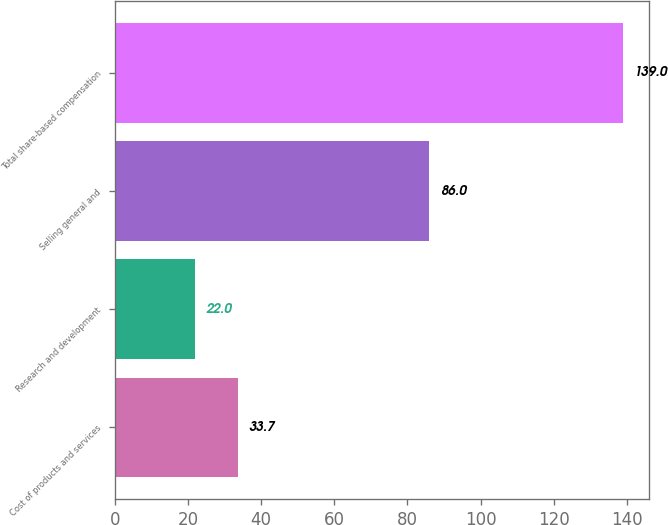Convert chart to OTSL. <chart><loc_0><loc_0><loc_500><loc_500><bar_chart><fcel>Cost of products and services<fcel>Research and development<fcel>Selling general and<fcel>Total share-based compensation<nl><fcel>33.7<fcel>22<fcel>86<fcel>139<nl></chart> 